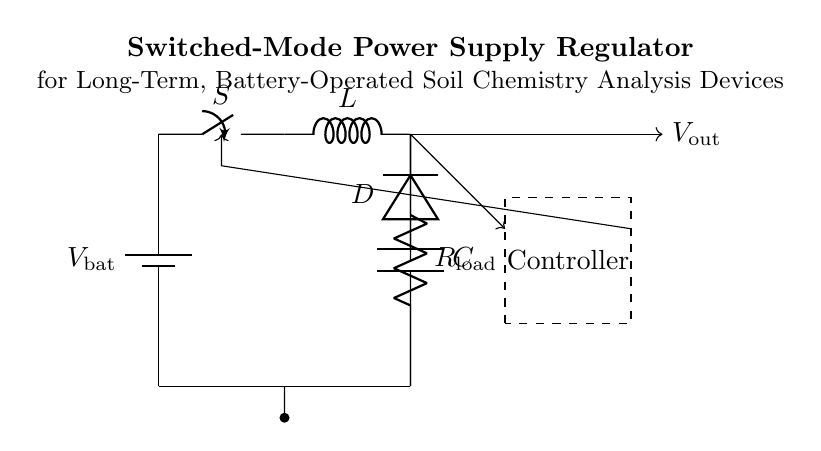What is the type of power supply in the circuit? The circuit is a switched-mode power supply, indicated by the presence of components such as a switch, inductor, diode, and capacitor working together to regulate voltage efficiently.
Answer: Switched-mode power supply What is the function of the switch? The switch in the circuit controls the flow of current through the inductor, allowing for energy storage and release, which is essential for regulating output voltage.
Answer: Control current flow What component is used to store energy? The inductor is the component that stores energy in the circuit when current flows through it, effectively aiding in voltage regulation.
Answer: Inductor What type of load is represented in the circuit? The load resistor is the component that draws power from the circuit, representing the device or sensor that requires voltage for operation in soil chemistry analysis.
Answer: Load resistor What is the relationship between the output voltage and the controller? The output voltage is monitored by the controller, which adjusts the operation of the switch based on feedback to maintain a set output voltage level.
Answer: Feedback adjustment How does the diode function in this circuit? The diode allows current to flow in one direction, thereby preventing backflow when the switch is off, thus protecting the circuit and ensuring it provides a stable output voltage.
Answer: Prevents backflow What should be the expected behavior of the circuit during battery operation? The circuit is designed to convert battery voltage into a stable output voltage while efficiently utilizing battery power for long-term operation in soil analysis devices.
Answer: Long-term stable output 